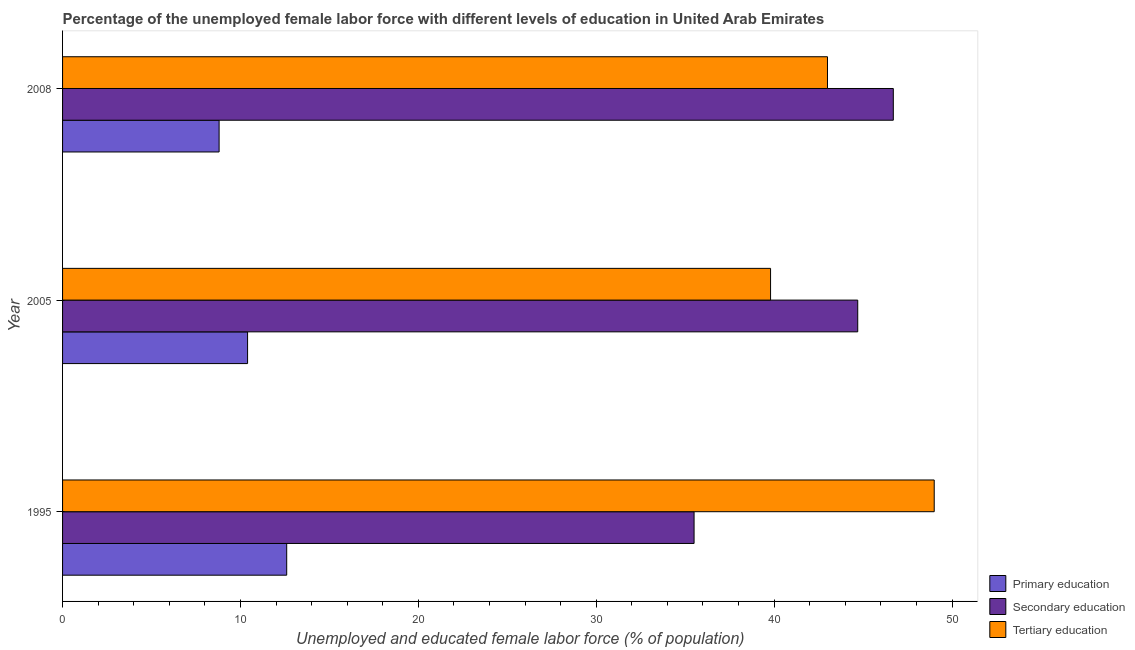How many groups of bars are there?
Offer a terse response. 3. Are the number of bars on each tick of the Y-axis equal?
Give a very brief answer. Yes. How many bars are there on the 2nd tick from the top?
Keep it short and to the point. 3. How many bars are there on the 3rd tick from the bottom?
Provide a short and direct response. 3. What is the label of the 3rd group of bars from the top?
Your response must be concise. 1995. What is the percentage of female labor force who received tertiary education in 2005?
Offer a very short reply. 39.8. Across all years, what is the maximum percentage of female labor force who received primary education?
Keep it short and to the point. 12.6. Across all years, what is the minimum percentage of female labor force who received primary education?
Offer a terse response. 8.8. In which year was the percentage of female labor force who received primary education minimum?
Provide a short and direct response. 2008. What is the total percentage of female labor force who received tertiary education in the graph?
Make the answer very short. 131.8. What is the difference between the percentage of female labor force who received primary education in 2005 and that in 2008?
Your response must be concise. 1.6. What is the difference between the percentage of female labor force who received tertiary education in 1995 and the percentage of female labor force who received secondary education in 2008?
Your response must be concise. 2.3. What is the average percentage of female labor force who received secondary education per year?
Your answer should be very brief. 42.3. In the year 1995, what is the difference between the percentage of female labor force who received tertiary education and percentage of female labor force who received primary education?
Provide a succinct answer. 36.4. What is the ratio of the percentage of female labor force who received secondary education in 1995 to that in 2005?
Offer a very short reply. 0.79. Is the difference between the percentage of female labor force who received tertiary education in 1995 and 2005 greater than the difference between the percentage of female labor force who received primary education in 1995 and 2005?
Offer a very short reply. Yes. What is the difference between the highest and the second highest percentage of female labor force who received secondary education?
Provide a succinct answer. 2. What is the difference between the highest and the lowest percentage of female labor force who received primary education?
Your answer should be compact. 3.8. What does the 2nd bar from the top in 1995 represents?
Offer a very short reply. Secondary education. What does the 2nd bar from the bottom in 1995 represents?
Your answer should be very brief. Secondary education. Is it the case that in every year, the sum of the percentage of female labor force who received primary education and percentage of female labor force who received secondary education is greater than the percentage of female labor force who received tertiary education?
Give a very brief answer. No. How many bars are there?
Ensure brevity in your answer.  9. How many years are there in the graph?
Your answer should be compact. 3. Are the values on the major ticks of X-axis written in scientific E-notation?
Your response must be concise. No. Does the graph contain any zero values?
Provide a succinct answer. No. Does the graph contain grids?
Ensure brevity in your answer.  No. How many legend labels are there?
Make the answer very short. 3. How are the legend labels stacked?
Your answer should be very brief. Vertical. What is the title of the graph?
Offer a very short reply. Percentage of the unemployed female labor force with different levels of education in United Arab Emirates. Does "Private sector" appear as one of the legend labels in the graph?
Provide a succinct answer. No. What is the label or title of the X-axis?
Your response must be concise. Unemployed and educated female labor force (% of population). What is the Unemployed and educated female labor force (% of population) of Primary education in 1995?
Ensure brevity in your answer.  12.6. What is the Unemployed and educated female labor force (% of population) of Secondary education in 1995?
Ensure brevity in your answer.  35.5. What is the Unemployed and educated female labor force (% of population) of Tertiary education in 1995?
Give a very brief answer. 49. What is the Unemployed and educated female labor force (% of population) in Primary education in 2005?
Provide a short and direct response. 10.4. What is the Unemployed and educated female labor force (% of population) of Secondary education in 2005?
Your response must be concise. 44.7. What is the Unemployed and educated female labor force (% of population) in Tertiary education in 2005?
Offer a terse response. 39.8. What is the Unemployed and educated female labor force (% of population) of Primary education in 2008?
Your answer should be compact. 8.8. What is the Unemployed and educated female labor force (% of population) in Secondary education in 2008?
Your answer should be very brief. 46.7. Across all years, what is the maximum Unemployed and educated female labor force (% of population) in Primary education?
Make the answer very short. 12.6. Across all years, what is the maximum Unemployed and educated female labor force (% of population) of Secondary education?
Offer a very short reply. 46.7. Across all years, what is the maximum Unemployed and educated female labor force (% of population) in Tertiary education?
Your response must be concise. 49. Across all years, what is the minimum Unemployed and educated female labor force (% of population) in Primary education?
Give a very brief answer. 8.8. Across all years, what is the minimum Unemployed and educated female labor force (% of population) of Secondary education?
Keep it short and to the point. 35.5. Across all years, what is the minimum Unemployed and educated female labor force (% of population) in Tertiary education?
Your answer should be very brief. 39.8. What is the total Unemployed and educated female labor force (% of population) in Primary education in the graph?
Your answer should be very brief. 31.8. What is the total Unemployed and educated female labor force (% of population) of Secondary education in the graph?
Your answer should be very brief. 126.9. What is the total Unemployed and educated female labor force (% of population) in Tertiary education in the graph?
Your answer should be very brief. 131.8. What is the difference between the Unemployed and educated female labor force (% of population) in Primary education in 1995 and that in 2005?
Ensure brevity in your answer.  2.2. What is the difference between the Unemployed and educated female labor force (% of population) of Tertiary education in 1995 and that in 2005?
Make the answer very short. 9.2. What is the difference between the Unemployed and educated female labor force (% of population) in Secondary education in 1995 and that in 2008?
Offer a very short reply. -11.2. What is the difference between the Unemployed and educated female labor force (% of population) in Primary education in 1995 and the Unemployed and educated female labor force (% of population) in Secondary education in 2005?
Your answer should be compact. -32.1. What is the difference between the Unemployed and educated female labor force (% of population) of Primary education in 1995 and the Unemployed and educated female labor force (% of population) of Tertiary education in 2005?
Give a very brief answer. -27.2. What is the difference between the Unemployed and educated female labor force (% of population) of Secondary education in 1995 and the Unemployed and educated female labor force (% of population) of Tertiary education in 2005?
Give a very brief answer. -4.3. What is the difference between the Unemployed and educated female labor force (% of population) of Primary education in 1995 and the Unemployed and educated female labor force (% of population) of Secondary education in 2008?
Provide a short and direct response. -34.1. What is the difference between the Unemployed and educated female labor force (% of population) in Primary education in 1995 and the Unemployed and educated female labor force (% of population) in Tertiary education in 2008?
Give a very brief answer. -30.4. What is the difference between the Unemployed and educated female labor force (% of population) of Secondary education in 1995 and the Unemployed and educated female labor force (% of population) of Tertiary education in 2008?
Your response must be concise. -7.5. What is the difference between the Unemployed and educated female labor force (% of population) of Primary education in 2005 and the Unemployed and educated female labor force (% of population) of Secondary education in 2008?
Make the answer very short. -36.3. What is the difference between the Unemployed and educated female labor force (% of population) in Primary education in 2005 and the Unemployed and educated female labor force (% of population) in Tertiary education in 2008?
Your answer should be compact. -32.6. What is the average Unemployed and educated female labor force (% of population) in Secondary education per year?
Your response must be concise. 42.3. What is the average Unemployed and educated female labor force (% of population) in Tertiary education per year?
Make the answer very short. 43.93. In the year 1995, what is the difference between the Unemployed and educated female labor force (% of population) in Primary education and Unemployed and educated female labor force (% of population) in Secondary education?
Provide a succinct answer. -22.9. In the year 1995, what is the difference between the Unemployed and educated female labor force (% of population) of Primary education and Unemployed and educated female labor force (% of population) of Tertiary education?
Provide a succinct answer. -36.4. In the year 2005, what is the difference between the Unemployed and educated female labor force (% of population) of Primary education and Unemployed and educated female labor force (% of population) of Secondary education?
Your response must be concise. -34.3. In the year 2005, what is the difference between the Unemployed and educated female labor force (% of population) of Primary education and Unemployed and educated female labor force (% of population) of Tertiary education?
Offer a terse response. -29.4. In the year 2008, what is the difference between the Unemployed and educated female labor force (% of population) of Primary education and Unemployed and educated female labor force (% of population) of Secondary education?
Provide a succinct answer. -37.9. In the year 2008, what is the difference between the Unemployed and educated female labor force (% of population) in Primary education and Unemployed and educated female labor force (% of population) in Tertiary education?
Provide a succinct answer. -34.2. What is the ratio of the Unemployed and educated female labor force (% of population) of Primary education in 1995 to that in 2005?
Your answer should be compact. 1.21. What is the ratio of the Unemployed and educated female labor force (% of population) of Secondary education in 1995 to that in 2005?
Your answer should be very brief. 0.79. What is the ratio of the Unemployed and educated female labor force (% of population) in Tertiary education in 1995 to that in 2005?
Your answer should be very brief. 1.23. What is the ratio of the Unemployed and educated female labor force (% of population) of Primary education in 1995 to that in 2008?
Keep it short and to the point. 1.43. What is the ratio of the Unemployed and educated female labor force (% of population) in Secondary education in 1995 to that in 2008?
Offer a terse response. 0.76. What is the ratio of the Unemployed and educated female labor force (% of population) of Tertiary education in 1995 to that in 2008?
Offer a very short reply. 1.14. What is the ratio of the Unemployed and educated female labor force (% of population) in Primary education in 2005 to that in 2008?
Ensure brevity in your answer.  1.18. What is the ratio of the Unemployed and educated female labor force (% of population) of Secondary education in 2005 to that in 2008?
Offer a terse response. 0.96. What is the ratio of the Unemployed and educated female labor force (% of population) in Tertiary education in 2005 to that in 2008?
Make the answer very short. 0.93. What is the difference between the highest and the lowest Unemployed and educated female labor force (% of population) of Primary education?
Ensure brevity in your answer.  3.8. What is the difference between the highest and the lowest Unemployed and educated female labor force (% of population) in Tertiary education?
Provide a short and direct response. 9.2. 